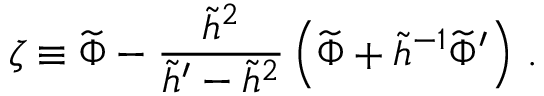Convert formula to latex. <formula><loc_0><loc_0><loc_500><loc_500>\zeta \equiv \widetilde { \Phi } - { \frac { \widetilde { h } ^ { 2 } } { \widetilde { h } ^ { \prime } - \widetilde { h } ^ { 2 } } } \left ( \widetilde { \Phi } + \widetilde { h } ^ { - 1 } \widetilde { \Phi } ^ { \prime } \right ) \, .</formula> 